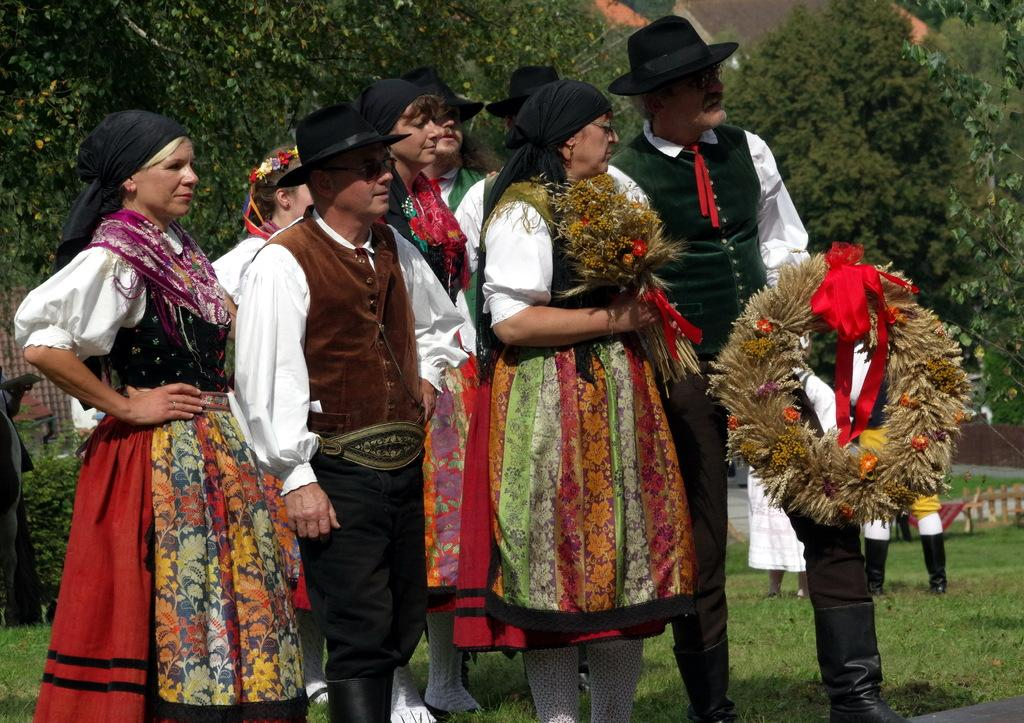How many people are in the image? There is a group of people in the image. What are two of the people holding? One person is holding a wreath, and another person is holding a flower bouquet. What can be seen in the background of the image? There are trees in the background of the image. What type of stitch is being used to sew the goat's fur in the image? There is no goat or any mention of sewing in the image. 